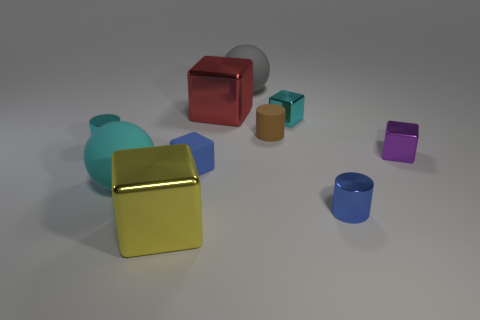There is a rubber thing that is the same shape as the large red shiny object; what size is it?
Provide a succinct answer. Small. How big is the matte sphere that is to the right of the big metal object in front of the blue thing that is right of the blue rubber object?
Your answer should be very brief. Large. How many other things are there of the same color as the tiny matte block?
Ensure brevity in your answer.  1. The blue shiny thing that is the same size as the purple thing is what shape?
Make the answer very short. Cylinder. There is a metal cylinder that is left of the rubber cylinder; what is its size?
Make the answer very short. Small. There is a tiny metallic cube behind the brown cylinder; is its color the same as the shiny object that is on the left side of the big cyan ball?
Keep it short and to the point. Yes. What is the material of the blue object behind the big cyan thing that is in front of the sphere behind the cyan metal cylinder?
Your answer should be compact. Rubber. Is there a yellow rubber cube of the same size as the cyan shiny cube?
Provide a short and direct response. No. There is a gray thing that is the same size as the cyan sphere; what material is it?
Provide a succinct answer. Rubber. There is a big metal thing behind the big cyan thing; what shape is it?
Provide a short and direct response. Cube. 